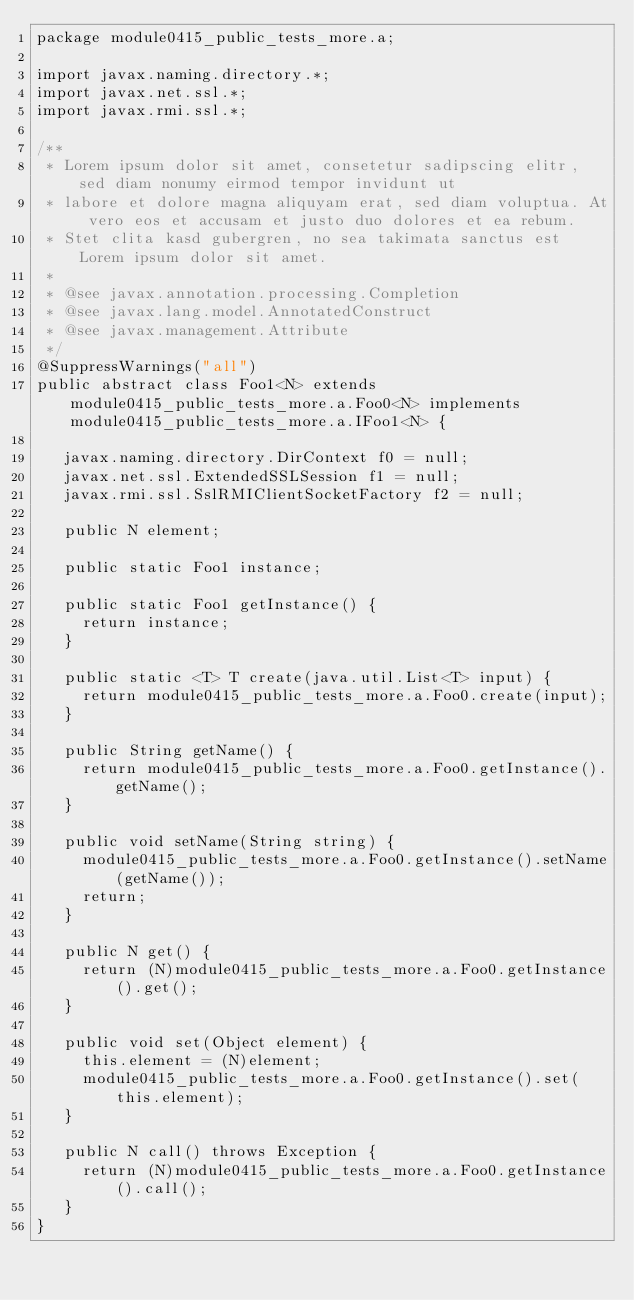Convert code to text. <code><loc_0><loc_0><loc_500><loc_500><_Java_>package module0415_public_tests_more.a;

import javax.naming.directory.*;
import javax.net.ssl.*;
import javax.rmi.ssl.*;

/**
 * Lorem ipsum dolor sit amet, consetetur sadipscing elitr, sed diam nonumy eirmod tempor invidunt ut 
 * labore et dolore magna aliquyam erat, sed diam voluptua. At vero eos et accusam et justo duo dolores et ea rebum. 
 * Stet clita kasd gubergren, no sea takimata sanctus est Lorem ipsum dolor sit amet. 
 *
 * @see javax.annotation.processing.Completion
 * @see javax.lang.model.AnnotatedConstruct
 * @see javax.management.Attribute
 */
@SuppressWarnings("all")
public abstract class Foo1<N> extends module0415_public_tests_more.a.Foo0<N> implements module0415_public_tests_more.a.IFoo1<N> {

	 javax.naming.directory.DirContext f0 = null;
	 javax.net.ssl.ExtendedSSLSession f1 = null;
	 javax.rmi.ssl.SslRMIClientSocketFactory f2 = null;

	 public N element;

	 public static Foo1 instance;

	 public static Foo1 getInstance() {
	 	 return instance;
	 }

	 public static <T> T create(java.util.List<T> input) {
	 	 return module0415_public_tests_more.a.Foo0.create(input);
	 }

	 public String getName() {
	 	 return module0415_public_tests_more.a.Foo0.getInstance().getName();
	 }

	 public void setName(String string) {
	 	 module0415_public_tests_more.a.Foo0.getInstance().setName(getName());
	 	 return;
	 }

	 public N get() {
	 	 return (N)module0415_public_tests_more.a.Foo0.getInstance().get();
	 }

	 public void set(Object element) {
	 	 this.element = (N)element;
	 	 module0415_public_tests_more.a.Foo0.getInstance().set(this.element);
	 }

	 public N call() throws Exception {
	 	 return (N)module0415_public_tests_more.a.Foo0.getInstance().call();
	 }
}
</code> 